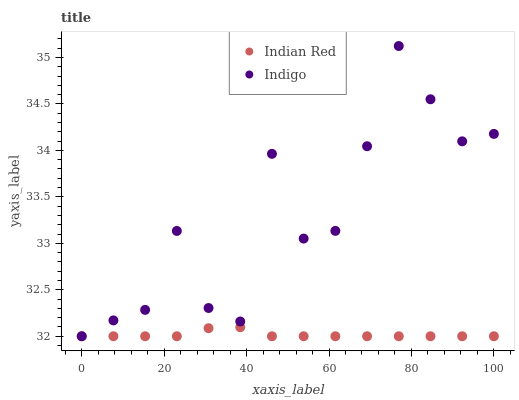Does Indian Red have the minimum area under the curve?
Answer yes or no. Yes. Does Indigo have the maximum area under the curve?
Answer yes or no. Yes. Does Indian Red have the maximum area under the curve?
Answer yes or no. No. Is Indian Red the smoothest?
Answer yes or no. Yes. Is Indigo the roughest?
Answer yes or no. Yes. Is Indian Red the roughest?
Answer yes or no. No. Does Indigo have the lowest value?
Answer yes or no. Yes. Does Indigo have the highest value?
Answer yes or no. Yes. Does Indian Red have the highest value?
Answer yes or no. No. Does Indigo intersect Indian Red?
Answer yes or no. Yes. Is Indigo less than Indian Red?
Answer yes or no. No. Is Indigo greater than Indian Red?
Answer yes or no. No. 